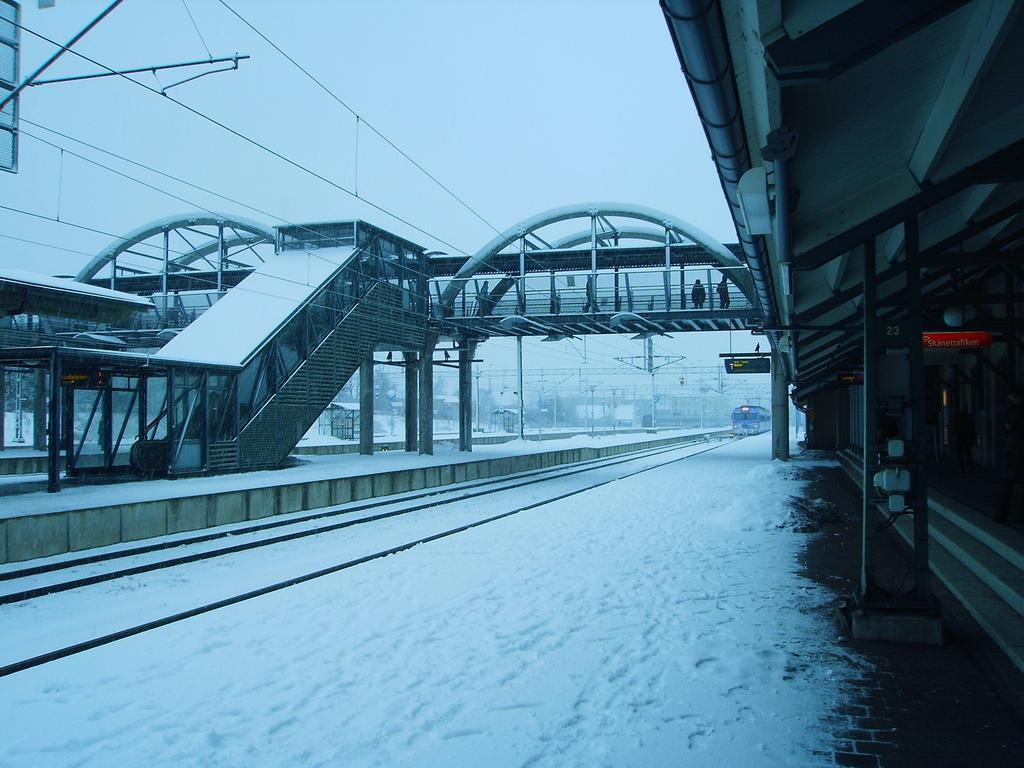Describe this image in one or two sentences. In this image there is a railway station that is covered with snow, on the right side there is a platform, in the background there is a foot over bridge, poles and wires and there are tracks, at the top there is the sky. 